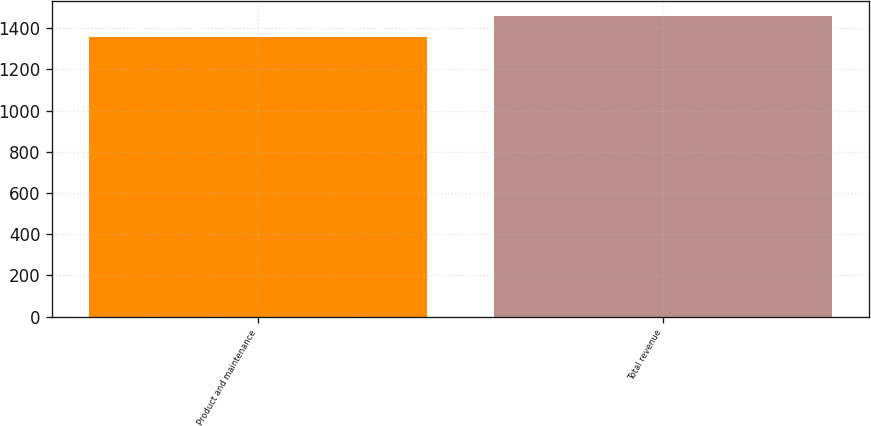<chart> <loc_0><loc_0><loc_500><loc_500><bar_chart><fcel>Product and maintenance<fcel>Total revenue<nl><fcel>1357.9<fcel>1460.1<nl></chart> 